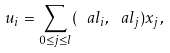<formula> <loc_0><loc_0><loc_500><loc_500>u _ { i } = \sum _ { 0 \leq j \leq l } ( \ a l _ { i } , \ a l _ { j } ) x _ { j } ,</formula> 